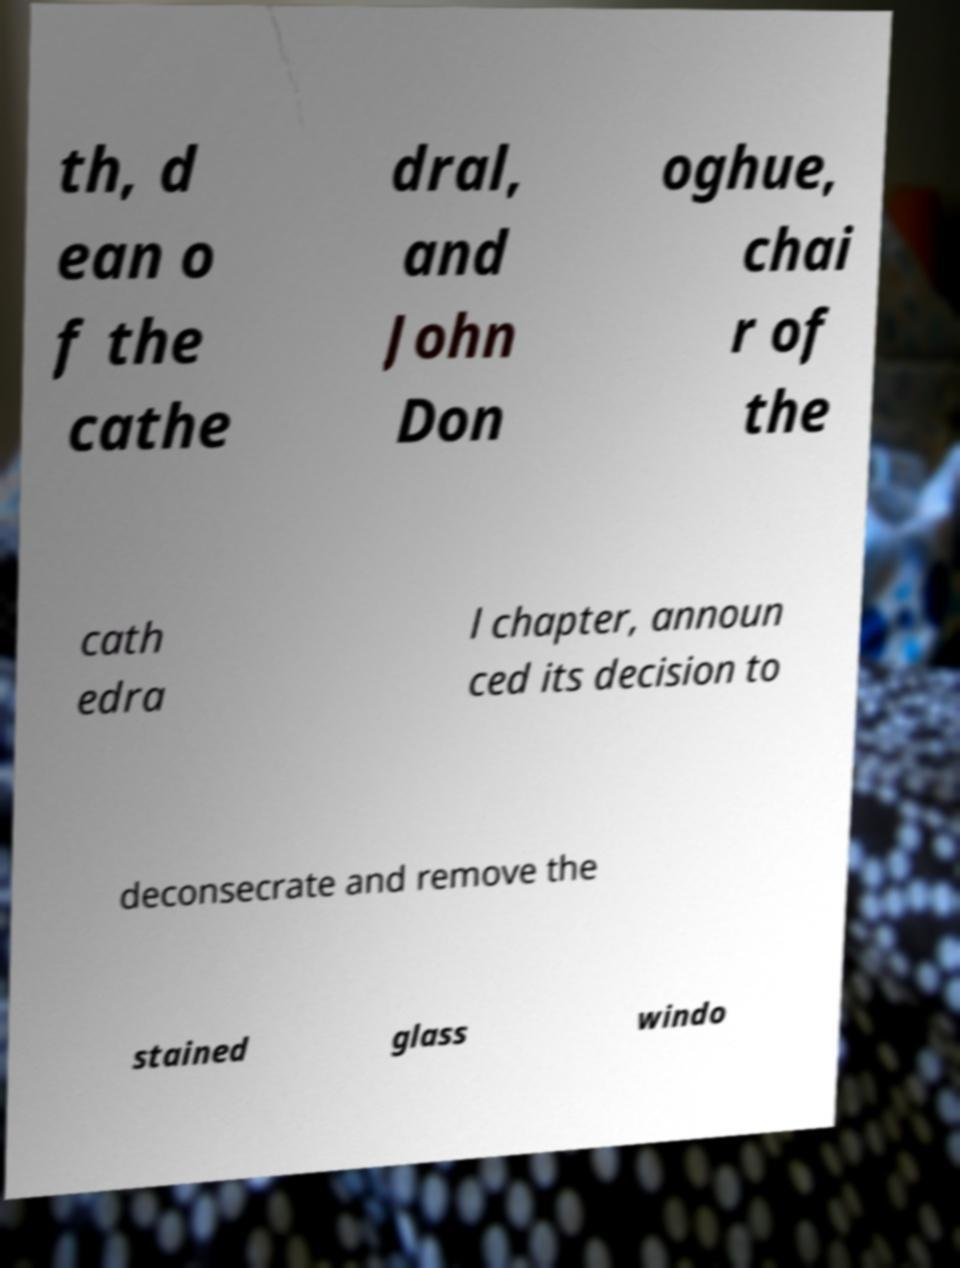What messages or text are displayed in this image? I need them in a readable, typed format. th, d ean o f the cathe dral, and John Don oghue, chai r of the cath edra l chapter, announ ced its decision to deconsecrate and remove the stained glass windo 